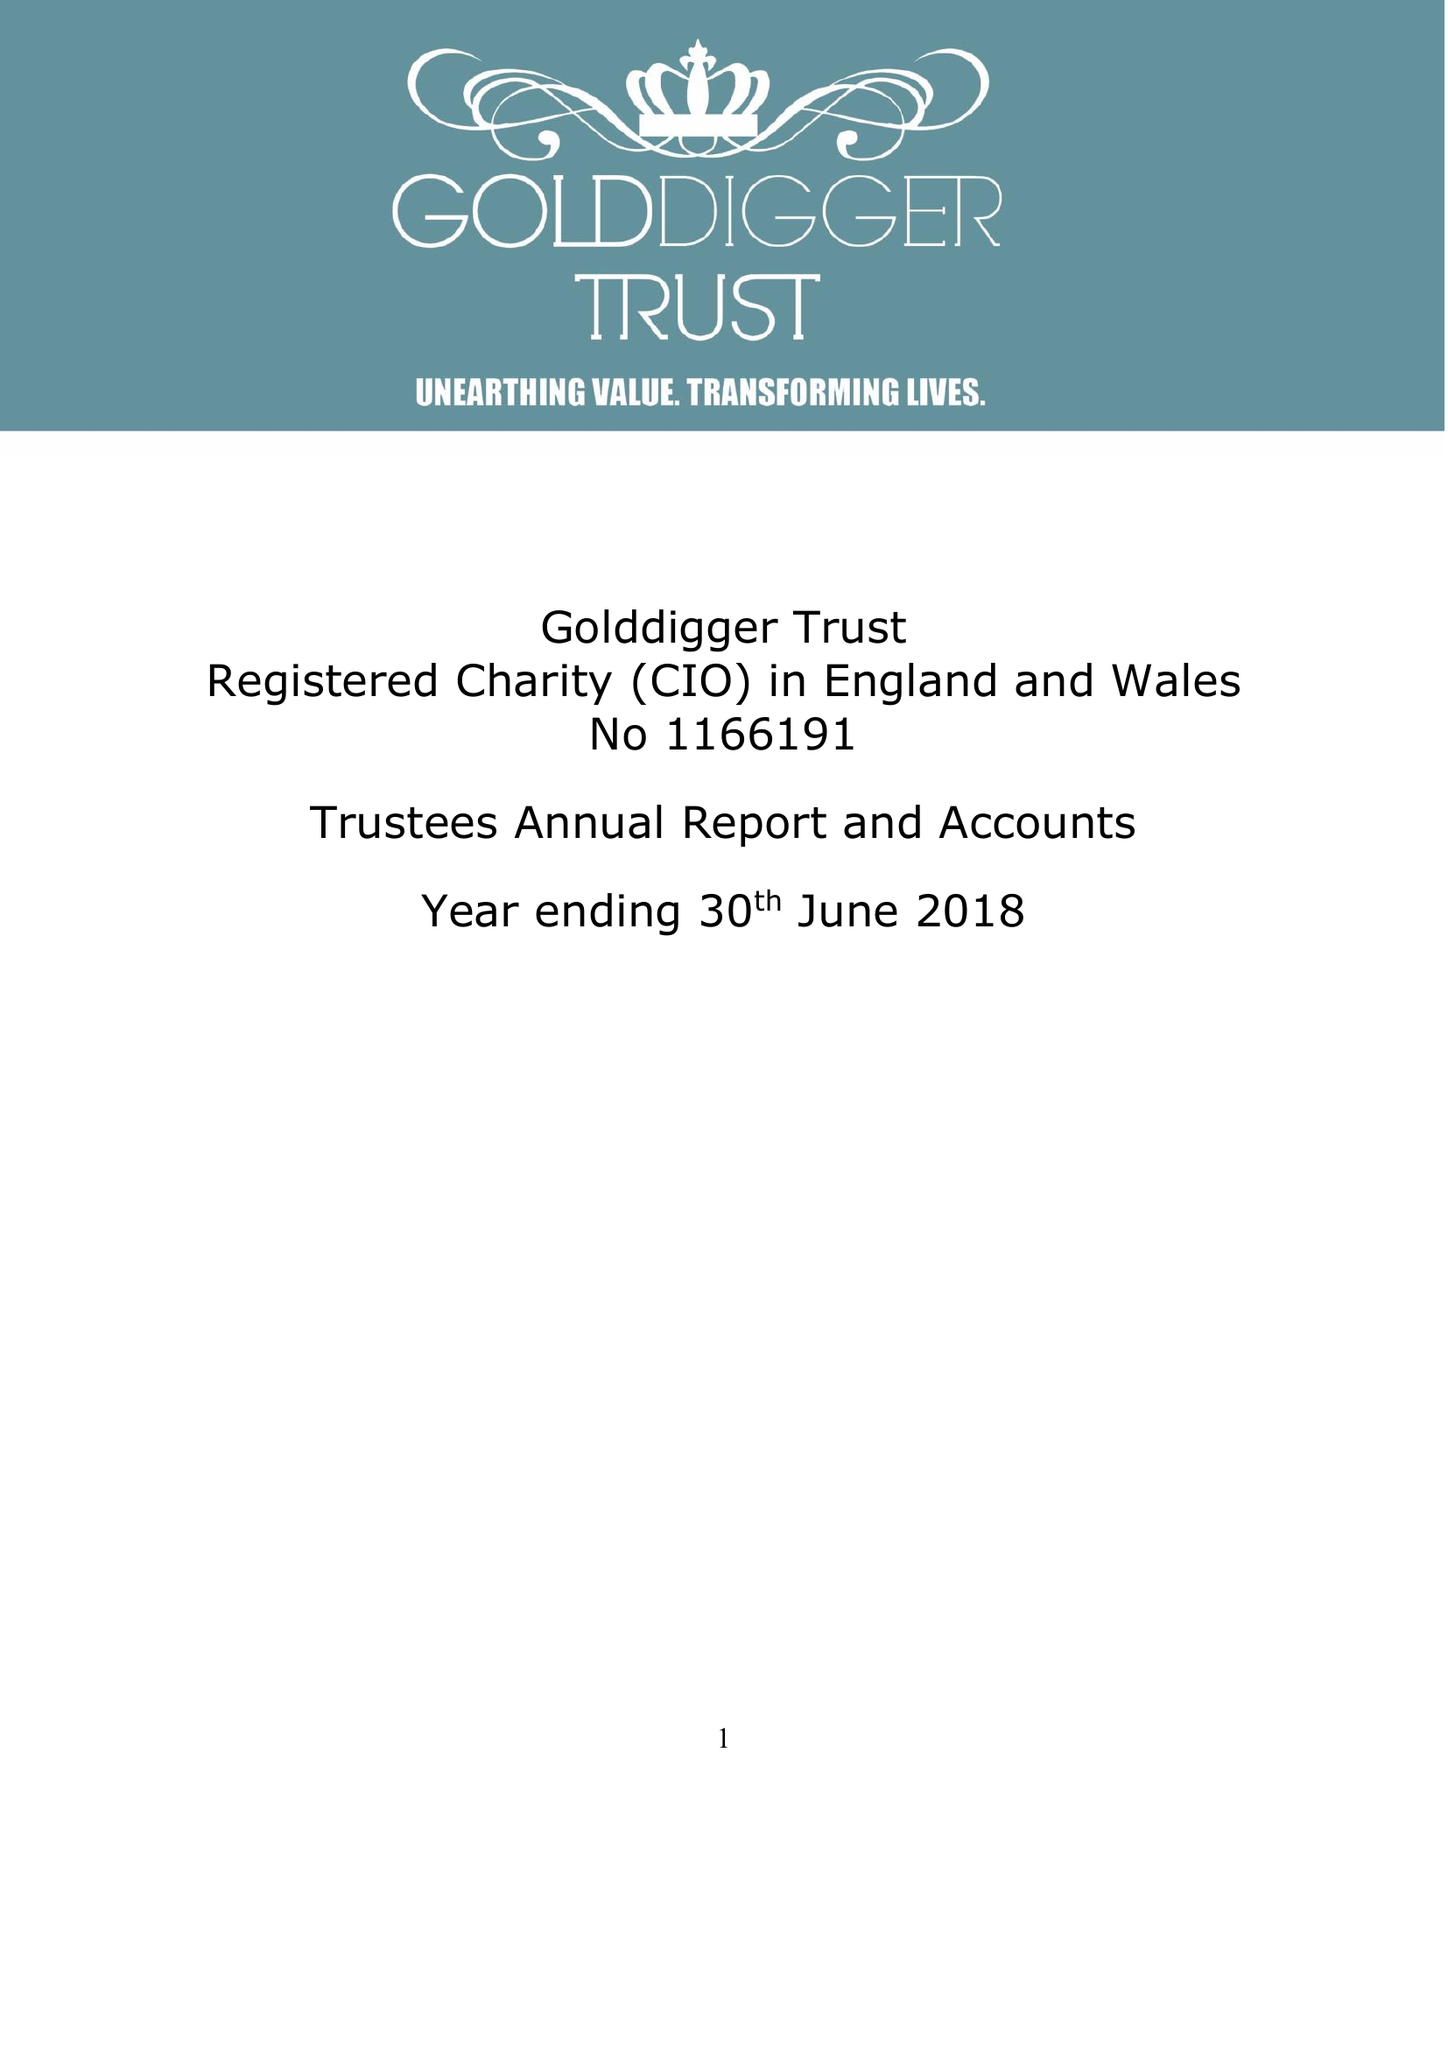What is the value for the spending_annually_in_british_pounds?
Answer the question using a single word or phrase. 150998.00 